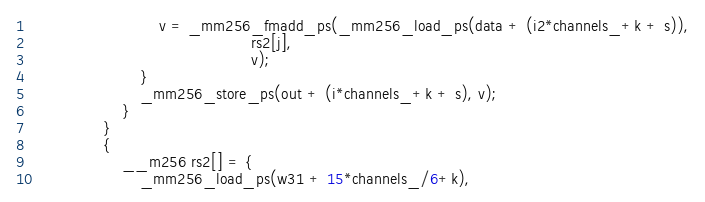<code> <loc_0><loc_0><loc_500><loc_500><_C++_>                            v = _mm256_fmadd_ps(_mm256_load_ps(data + (i2*channels_+k + s)),
                                                rs2[j],
                                                v);
                        }
                        _mm256_store_ps(out + (i*channels_+k + s), v);
                    }
                }
                {
                    __m256 rs2[] = {
                        _mm256_load_ps(w31 + 15*channels_/6+k),</code> 